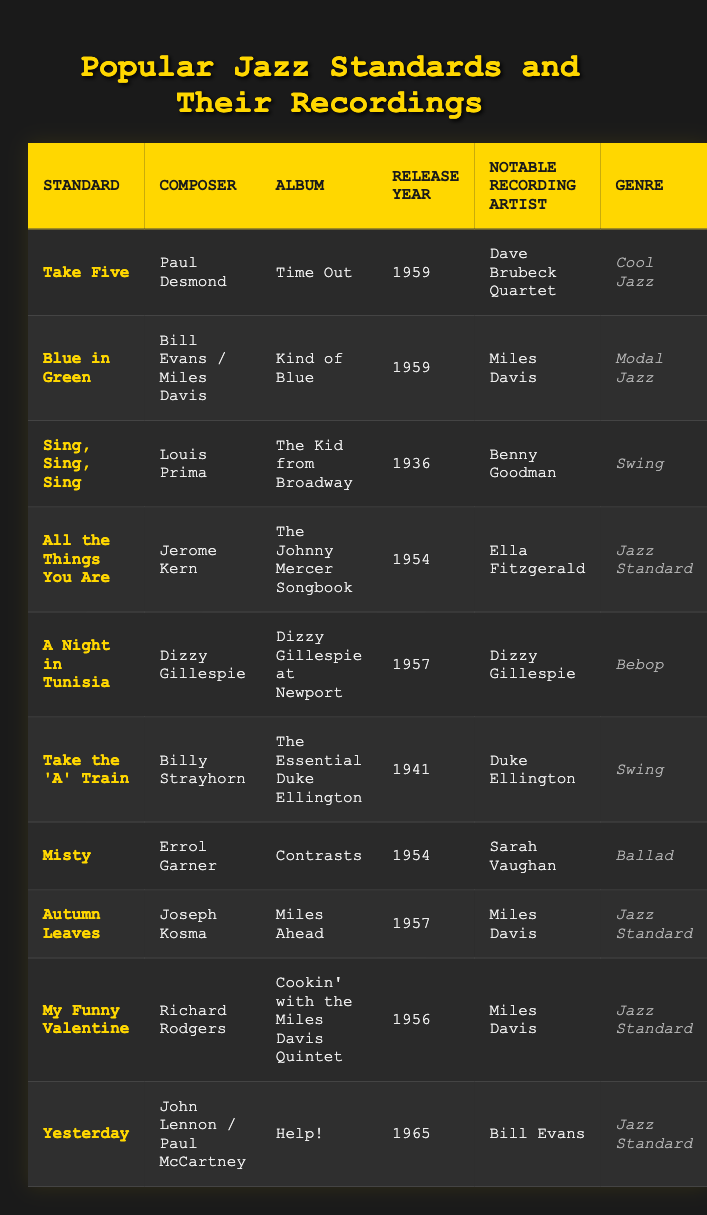What is the release year of "Take Five"? The table lists "Take Five" as being released in 1959 under the album "Time Out."
Answer: 1959 Who composed "Misty"? The composer of "Misty" is listed as Errol Garner in the table.
Answer: Errol Garner Which artist recorded "Yesterday"? According to the table, Bill Evans is the notable recording artist of "Yesterday."
Answer: Bill Evans What genre does "A Night in Tunisia" belong to? The genre for "A Night in Tunisia" is categorized as Bebop in the table.
Answer: Bebop How many jazz standards were released in 1959? There are three standards ("Take Five," "Blue in Green," and "Autumn Leaves") that were released in 1959.
Answer: 3 Was "Sing, Sing, Sing" released before 1940? The table shows that "Sing, Sing, Sing" was released in 1936, which is before 1940.
Answer: Yes Which artist has the most notable recordings in the table? Looking at the table, Miles Davis has three notable recordings: "Blue in Green," "Autumn Leaves," and "My Funny Valentine."
Answer: Miles Davis What is the difference in release years between "All the Things You Are" and "Take the 'A' Train"? "All the Things You Are" was released in 1954 and "Take the 'A' Train" in 1941. The difference is 1954 - 1941 = 13 years.
Answer: 13 years Is "Autumn Leaves" categorized as a Jazz Standard? The table categorizes "Autumn Leaves" under the genre "Jazz Standard."
Answer: Yes What is the earliest recorded jazz standard on the table? The earliest recorded jazz standard is "Sing, Sing, Sing," which was released in 1936.
Answer: Sing, Sing, Sing How many jazz records in the table are from the '50s decade? The records from the '50s are "Take Five" (1959), "Blue in Green" (1959), "Misty" (1954), "A Night in Tunisia" (1957), "Autumn Leaves" (1957), "My Funny Valentine" (1956), and "Yesterday" (1965). This makes a total of 7 records.
Answer: 7 